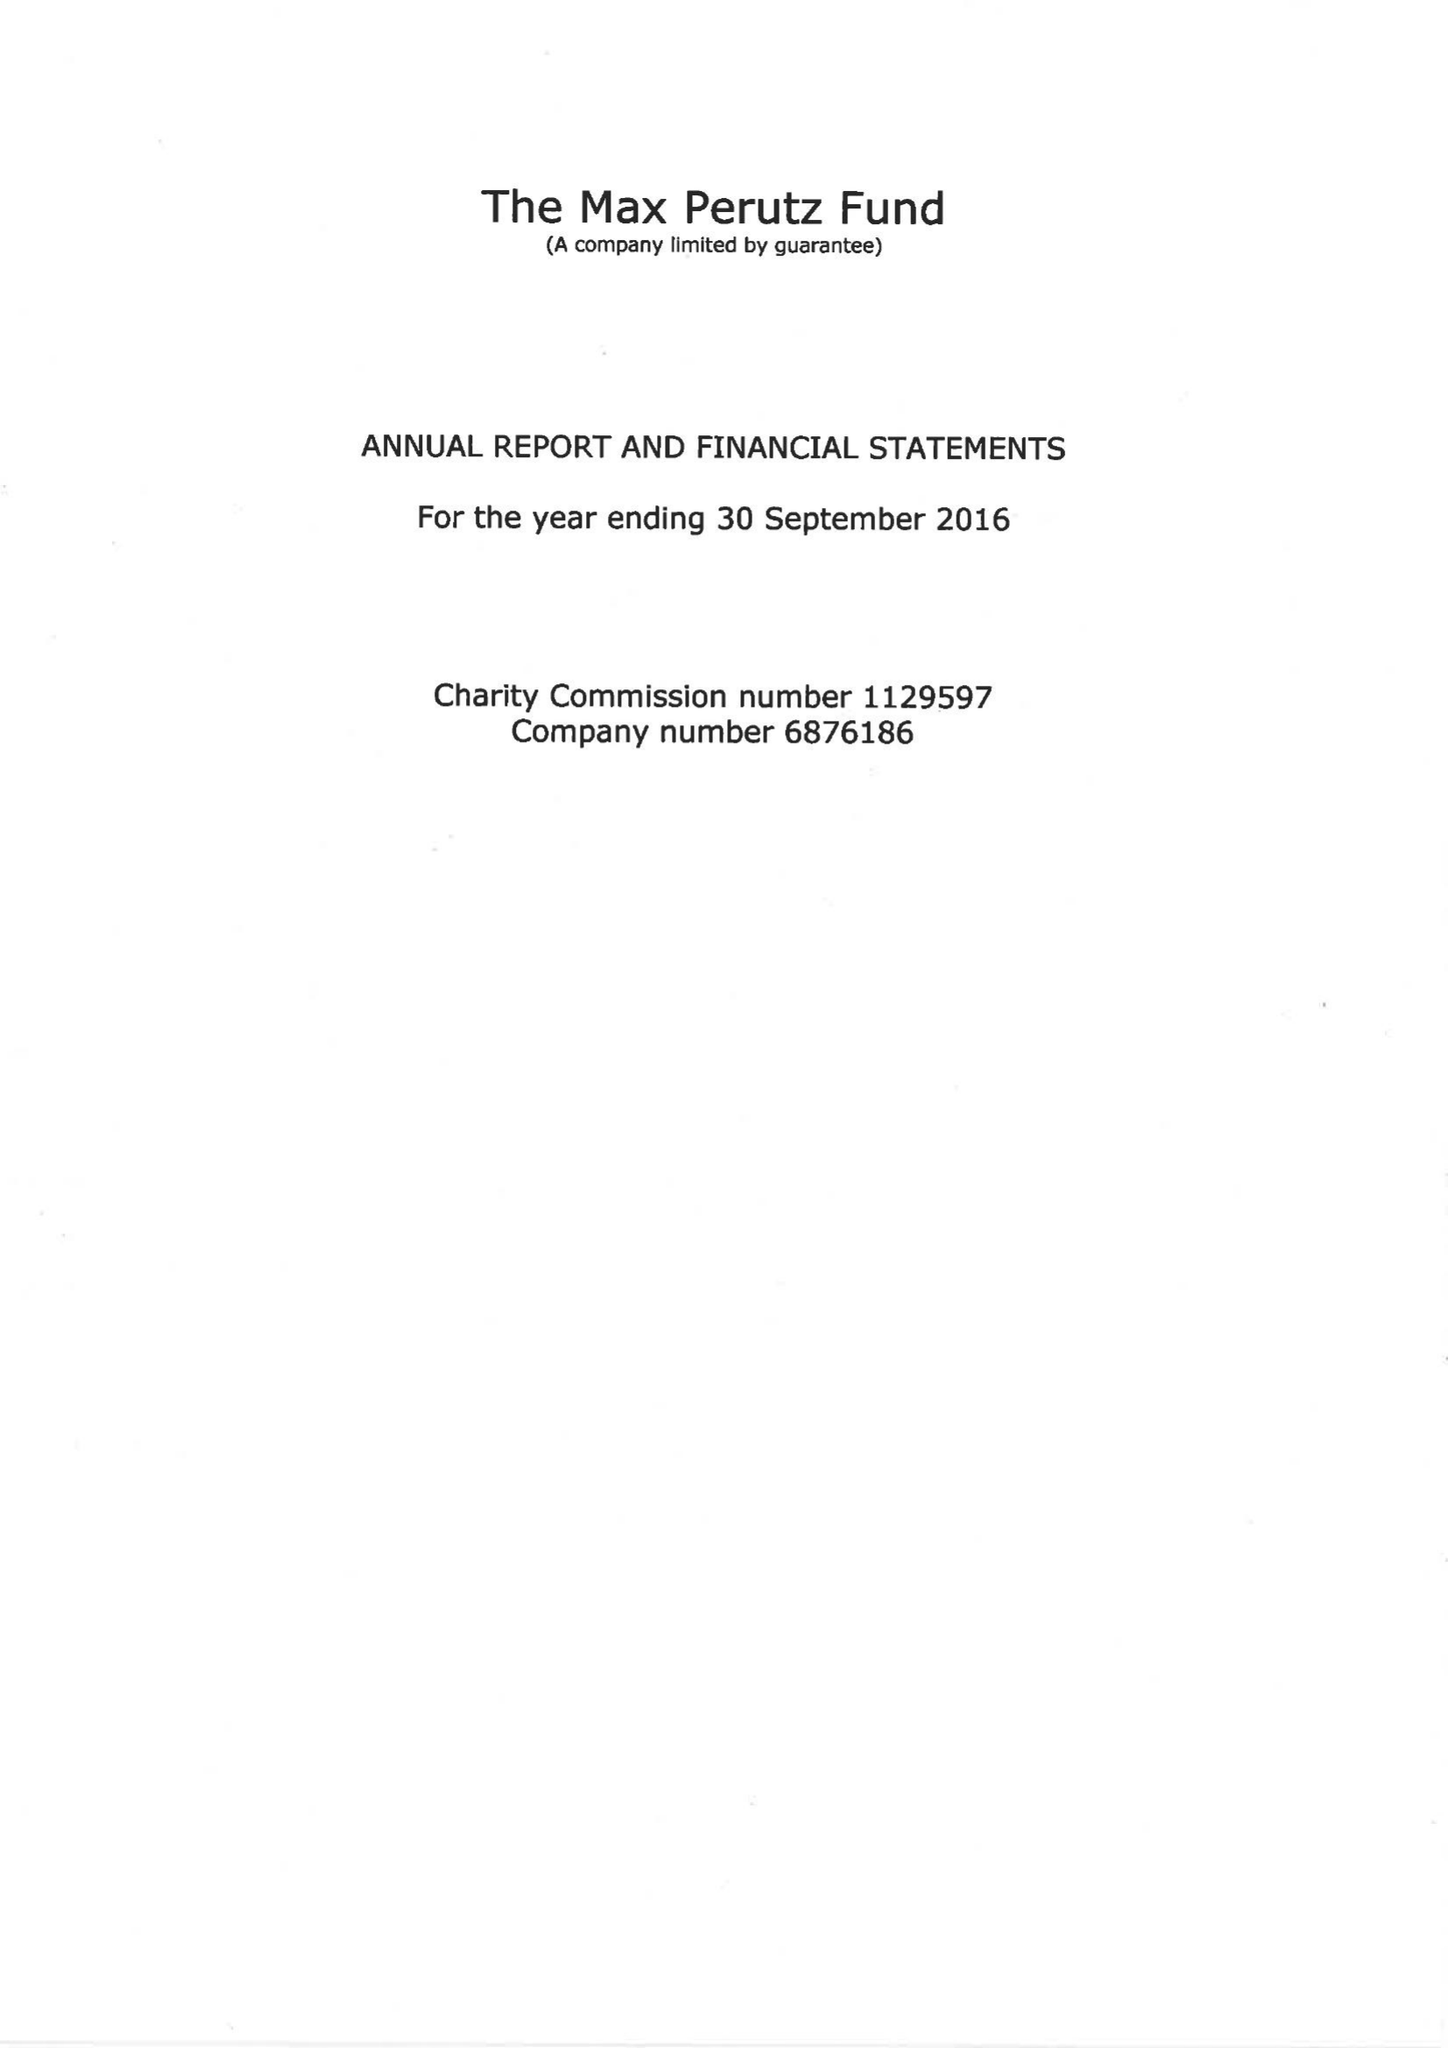What is the value for the address__post_town?
Answer the question using a single word or phrase. CAMBRIDGE 